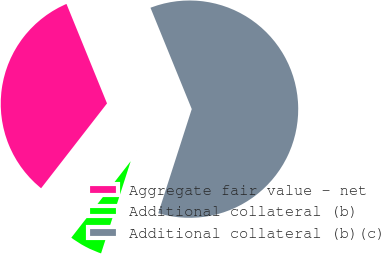Convert chart. <chart><loc_0><loc_0><loc_500><loc_500><pie_chart><fcel>Aggregate fair value - net<fcel>Additional collateral (b)<fcel>Additional collateral (b)(c)<nl><fcel>33.33%<fcel>5.56%<fcel>61.11%<nl></chart> 